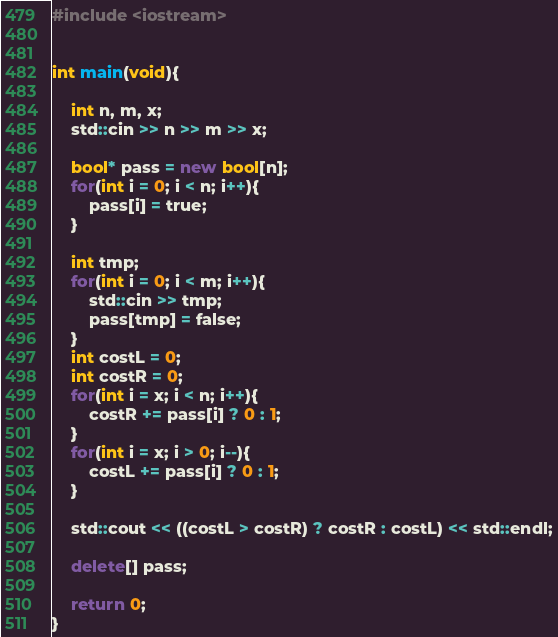Convert code to text. <code><loc_0><loc_0><loc_500><loc_500><_C++_>#include <iostream>


int main(void){

	int n, m, x;
	std::cin >> n >> m >> x;

	bool* pass = new bool[n];
	for(int i = 0; i < n; i++){
		pass[i] = true;
	}

	int tmp;
	for(int i = 0; i < m; i++){
		std::cin >> tmp;
		pass[tmp] = false;
	}
	int costL = 0;
	int costR = 0;
	for(int i = x; i < n; i++){
		costR += pass[i] ? 0 : 1;
	}
	for(int i = x; i > 0; i--){
		costL += pass[i] ? 0 : 1;
	}
	
	std::cout << ((costL > costR) ? costR : costL) << std::endl;

	delete[] pass;

	return 0;
}</code> 